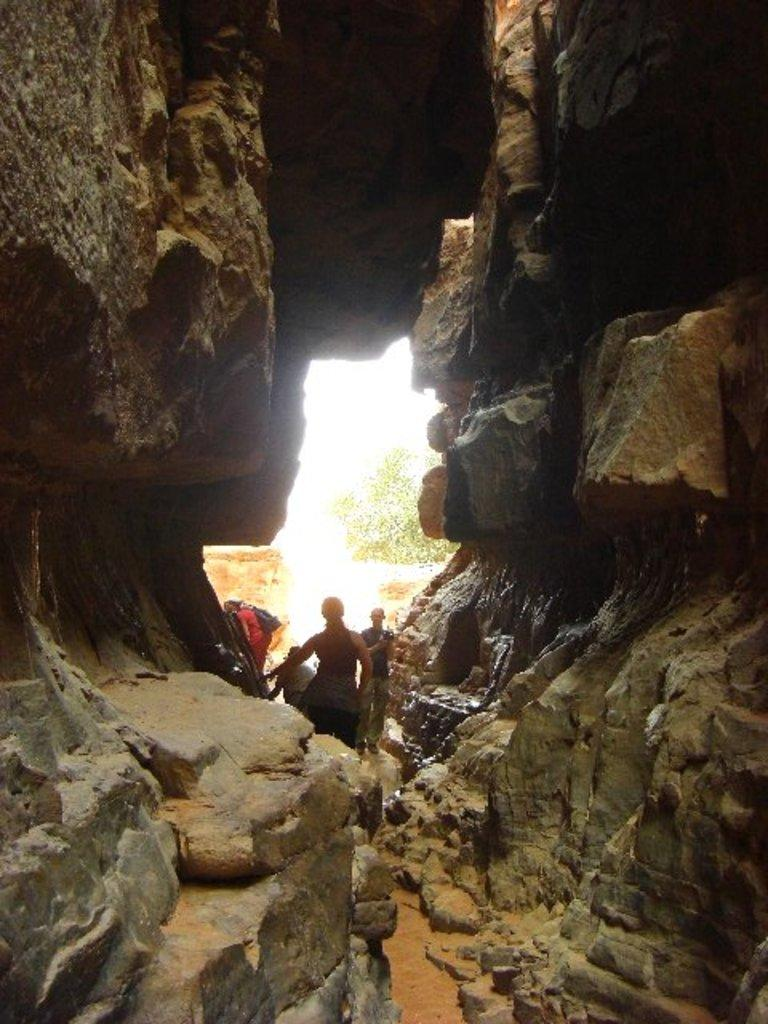What is the main subject in the center of the image? There are people in the center of the image. What can be seen on the right side of the image? There are rocks on the right side of the image. What can be seen on the left side of the image? There are rocks on the left side of the image. What is visible in the background of the image? There is a tree in the background of the image. What type of shoes are the people wearing in the image? The provided facts do not mention any shoes, so we cannot determine what type of shoes the people are wearing in the image. 